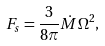<formula> <loc_0><loc_0><loc_500><loc_500>F _ { s } = \frac { 3 } { 8 \pi } \dot { M } \Omega ^ { 2 } ,</formula> 